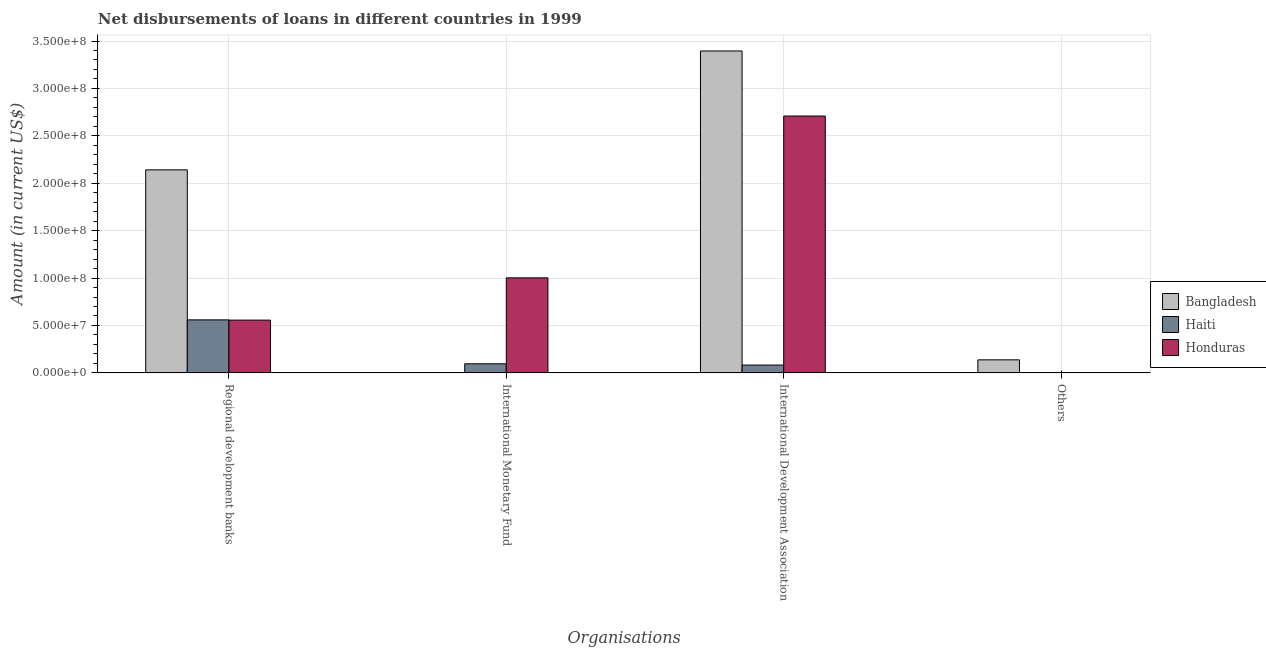How many different coloured bars are there?
Your answer should be very brief. 3. How many bars are there on the 3rd tick from the left?
Your response must be concise. 3. What is the label of the 3rd group of bars from the left?
Provide a succinct answer. International Development Association. What is the amount of loan disimbursed by international monetary fund in Haiti?
Keep it short and to the point. 9.57e+06. Across all countries, what is the maximum amount of loan disimbursed by international development association?
Make the answer very short. 3.39e+08. Across all countries, what is the minimum amount of loan disimbursed by other organisations?
Make the answer very short. 0. In which country was the amount of loan disimbursed by international monetary fund maximum?
Give a very brief answer. Honduras. What is the total amount of loan disimbursed by international development association in the graph?
Provide a short and direct response. 6.19e+08. What is the difference between the amount of loan disimbursed by international development association in Bangladesh and that in Haiti?
Ensure brevity in your answer.  3.31e+08. What is the difference between the amount of loan disimbursed by international monetary fund in Haiti and the amount of loan disimbursed by international development association in Bangladesh?
Give a very brief answer. -3.30e+08. What is the average amount of loan disimbursed by other organisations per country?
Provide a short and direct response. 4.58e+06. What is the difference between the amount of loan disimbursed by regional development banks and amount of loan disimbursed by other organisations in Bangladesh?
Your answer should be very brief. 2.00e+08. In how many countries, is the amount of loan disimbursed by regional development banks greater than 250000000 US$?
Keep it short and to the point. 0. What is the ratio of the amount of loan disimbursed by regional development banks in Bangladesh to that in Haiti?
Ensure brevity in your answer.  3.83. What is the difference between the highest and the second highest amount of loan disimbursed by international development association?
Your answer should be compact. 6.86e+07. What is the difference between the highest and the lowest amount of loan disimbursed by international development association?
Your answer should be very brief. 3.31e+08. Is it the case that in every country, the sum of the amount of loan disimbursed by regional development banks and amount of loan disimbursed by international monetary fund is greater than the sum of amount of loan disimbursed by other organisations and amount of loan disimbursed by international development association?
Your answer should be compact. No. How many bars are there?
Make the answer very short. 9. What is the difference between two consecutive major ticks on the Y-axis?
Your response must be concise. 5.00e+07. How are the legend labels stacked?
Your response must be concise. Vertical. What is the title of the graph?
Keep it short and to the point. Net disbursements of loans in different countries in 1999. What is the label or title of the X-axis?
Your answer should be compact. Organisations. What is the Amount (in current US$) in Bangladesh in Regional development banks?
Provide a short and direct response. 2.14e+08. What is the Amount (in current US$) of Haiti in Regional development banks?
Offer a very short reply. 5.59e+07. What is the Amount (in current US$) of Honduras in Regional development banks?
Ensure brevity in your answer.  5.56e+07. What is the Amount (in current US$) of Bangladesh in International Monetary Fund?
Your response must be concise. 0. What is the Amount (in current US$) of Haiti in International Monetary Fund?
Offer a terse response. 9.57e+06. What is the Amount (in current US$) in Honduras in International Monetary Fund?
Make the answer very short. 1.00e+08. What is the Amount (in current US$) of Bangladesh in International Development Association?
Offer a terse response. 3.39e+08. What is the Amount (in current US$) of Haiti in International Development Association?
Your response must be concise. 8.23e+06. What is the Amount (in current US$) in Honduras in International Development Association?
Ensure brevity in your answer.  2.71e+08. What is the Amount (in current US$) in Bangladesh in Others?
Provide a succinct answer. 1.37e+07. Across all Organisations, what is the maximum Amount (in current US$) of Bangladesh?
Offer a very short reply. 3.39e+08. Across all Organisations, what is the maximum Amount (in current US$) of Haiti?
Make the answer very short. 5.59e+07. Across all Organisations, what is the maximum Amount (in current US$) of Honduras?
Make the answer very short. 2.71e+08. Across all Organisations, what is the minimum Amount (in current US$) of Haiti?
Provide a short and direct response. 0. Across all Organisations, what is the minimum Amount (in current US$) in Honduras?
Provide a short and direct response. 0. What is the total Amount (in current US$) of Bangladesh in the graph?
Offer a terse response. 5.67e+08. What is the total Amount (in current US$) in Haiti in the graph?
Offer a terse response. 7.37e+07. What is the total Amount (in current US$) in Honduras in the graph?
Your answer should be very brief. 4.27e+08. What is the difference between the Amount (in current US$) in Haiti in Regional development banks and that in International Monetary Fund?
Provide a succinct answer. 4.63e+07. What is the difference between the Amount (in current US$) of Honduras in Regional development banks and that in International Monetary Fund?
Ensure brevity in your answer.  -4.46e+07. What is the difference between the Amount (in current US$) of Bangladesh in Regional development banks and that in International Development Association?
Give a very brief answer. -1.25e+08. What is the difference between the Amount (in current US$) in Haiti in Regional development banks and that in International Development Association?
Your response must be concise. 4.77e+07. What is the difference between the Amount (in current US$) of Honduras in Regional development banks and that in International Development Association?
Your response must be concise. -2.15e+08. What is the difference between the Amount (in current US$) of Bangladesh in Regional development banks and that in Others?
Offer a very short reply. 2.00e+08. What is the difference between the Amount (in current US$) in Haiti in International Monetary Fund and that in International Development Association?
Your response must be concise. 1.34e+06. What is the difference between the Amount (in current US$) in Honduras in International Monetary Fund and that in International Development Association?
Your answer should be very brief. -1.71e+08. What is the difference between the Amount (in current US$) of Bangladesh in International Development Association and that in Others?
Your answer should be very brief. 3.26e+08. What is the difference between the Amount (in current US$) of Bangladesh in Regional development banks and the Amount (in current US$) of Haiti in International Monetary Fund?
Offer a terse response. 2.05e+08. What is the difference between the Amount (in current US$) in Bangladesh in Regional development banks and the Amount (in current US$) in Honduras in International Monetary Fund?
Your answer should be very brief. 1.14e+08. What is the difference between the Amount (in current US$) of Haiti in Regional development banks and the Amount (in current US$) of Honduras in International Monetary Fund?
Make the answer very short. -4.43e+07. What is the difference between the Amount (in current US$) in Bangladesh in Regional development banks and the Amount (in current US$) in Haiti in International Development Association?
Give a very brief answer. 2.06e+08. What is the difference between the Amount (in current US$) in Bangladesh in Regional development banks and the Amount (in current US$) in Honduras in International Development Association?
Keep it short and to the point. -5.67e+07. What is the difference between the Amount (in current US$) in Haiti in Regional development banks and the Amount (in current US$) in Honduras in International Development Association?
Offer a terse response. -2.15e+08. What is the difference between the Amount (in current US$) of Haiti in International Monetary Fund and the Amount (in current US$) of Honduras in International Development Association?
Ensure brevity in your answer.  -2.61e+08. What is the average Amount (in current US$) of Bangladesh per Organisations?
Make the answer very short. 1.42e+08. What is the average Amount (in current US$) in Haiti per Organisations?
Give a very brief answer. 1.84e+07. What is the average Amount (in current US$) of Honduras per Organisations?
Your response must be concise. 1.07e+08. What is the difference between the Amount (in current US$) in Bangladesh and Amount (in current US$) in Haiti in Regional development banks?
Offer a very short reply. 1.58e+08. What is the difference between the Amount (in current US$) of Bangladesh and Amount (in current US$) of Honduras in Regional development banks?
Give a very brief answer. 1.58e+08. What is the difference between the Amount (in current US$) in Haiti and Amount (in current US$) in Honduras in Regional development banks?
Offer a very short reply. 2.63e+05. What is the difference between the Amount (in current US$) in Haiti and Amount (in current US$) in Honduras in International Monetary Fund?
Offer a terse response. -9.06e+07. What is the difference between the Amount (in current US$) of Bangladesh and Amount (in current US$) of Haiti in International Development Association?
Offer a terse response. 3.31e+08. What is the difference between the Amount (in current US$) of Bangladesh and Amount (in current US$) of Honduras in International Development Association?
Give a very brief answer. 6.86e+07. What is the difference between the Amount (in current US$) of Haiti and Amount (in current US$) of Honduras in International Development Association?
Offer a terse response. -2.63e+08. What is the ratio of the Amount (in current US$) in Haiti in Regional development banks to that in International Monetary Fund?
Ensure brevity in your answer.  5.84. What is the ratio of the Amount (in current US$) in Honduras in Regional development banks to that in International Monetary Fund?
Provide a succinct answer. 0.56. What is the ratio of the Amount (in current US$) of Bangladesh in Regional development banks to that in International Development Association?
Give a very brief answer. 0.63. What is the ratio of the Amount (in current US$) in Haiti in Regional development banks to that in International Development Association?
Provide a succinct answer. 6.79. What is the ratio of the Amount (in current US$) of Honduras in Regional development banks to that in International Development Association?
Offer a terse response. 0.21. What is the ratio of the Amount (in current US$) of Bangladesh in Regional development banks to that in Others?
Your response must be concise. 15.59. What is the ratio of the Amount (in current US$) in Haiti in International Monetary Fund to that in International Development Association?
Offer a very short reply. 1.16. What is the ratio of the Amount (in current US$) of Honduras in International Monetary Fund to that in International Development Association?
Ensure brevity in your answer.  0.37. What is the ratio of the Amount (in current US$) in Bangladesh in International Development Association to that in Others?
Offer a very short reply. 24.71. What is the difference between the highest and the second highest Amount (in current US$) in Bangladesh?
Give a very brief answer. 1.25e+08. What is the difference between the highest and the second highest Amount (in current US$) of Haiti?
Keep it short and to the point. 4.63e+07. What is the difference between the highest and the second highest Amount (in current US$) of Honduras?
Provide a short and direct response. 1.71e+08. What is the difference between the highest and the lowest Amount (in current US$) of Bangladesh?
Keep it short and to the point. 3.39e+08. What is the difference between the highest and the lowest Amount (in current US$) of Haiti?
Your answer should be compact. 5.59e+07. What is the difference between the highest and the lowest Amount (in current US$) of Honduras?
Keep it short and to the point. 2.71e+08. 